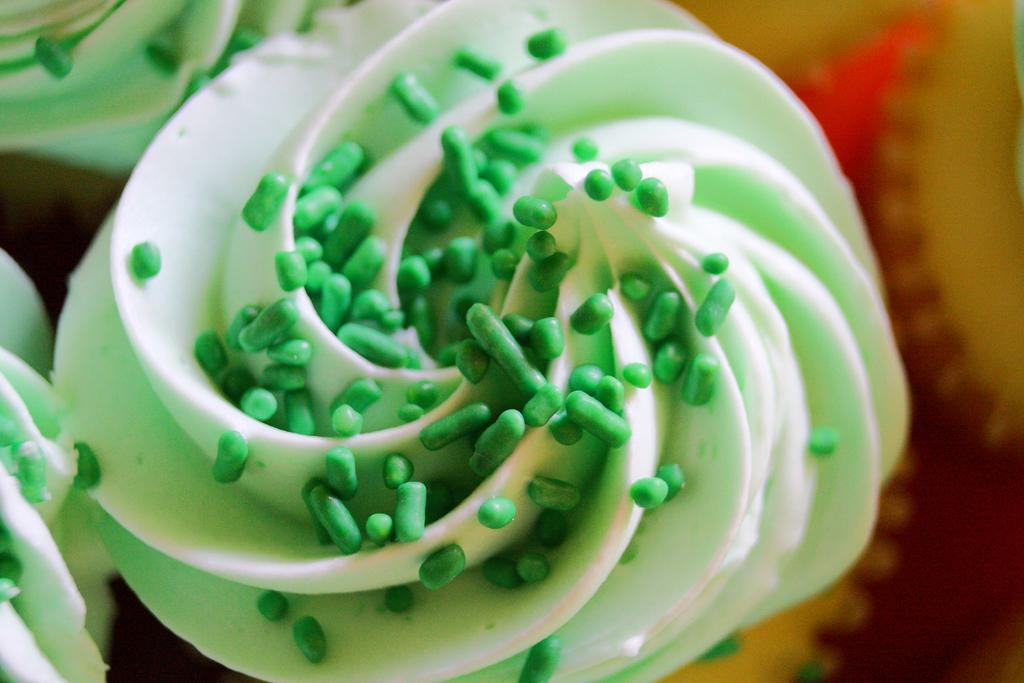What types of objects can be seen in the image? There are food items visible throughout the image. Can you describe the food items in more detail? Unfortunately, the provided facts do not offer specific details about the food items. Are there any non-food items visible in the image? The facts only mention food items, so it is not possible to determine if there are any non-food items present. How many people are currently in jail in the image? There is no reference to a jail or any people in the image, so it is not possible to answer that question. 